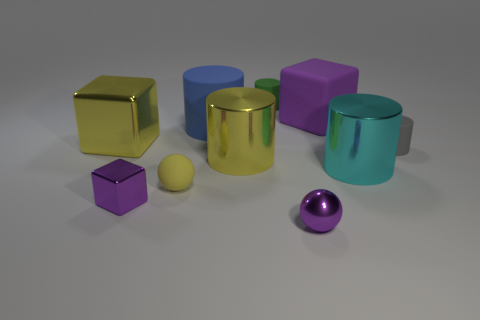There is a purple block that is behind the large yellow thing left of the purple shiny object that is on the left side of the tiny yellow sphere; what is it made of?
Your response must be concise. Rubber. Are there the same number of gray rubber objects on the right side of the purple matte cube and blocks?
Give a very brief answer. No. Are the large thing behind the blue cylinder and the big yellow thing behind the tiny gray rubber thing made of the same material?
Provide a short and direct response. No. What number of things are large purple rubber things or big cubes that are to the left of the purple rubber block?
Provide a short and direct response. 2. Are there any blue matte things of the same shape as the big cyan metallic thing?
Give a very brief answer. Yes. What size is the yellow metallic object in front of the large yellow object that is left of the purple block that is left of the yellow rubber thing?
Your answer should be compact. Large. Are there an equal number of metallic balls behind the purple ball and small shiny objects to the left of the gray matte cylinder?
Give a very brief answer. No. The blue cylinder that is made of the same material as the small green object is what size?
Give a very brief answer. Large. The tiny matte ball has what color?
Offer a terse response. Yellow. What number of rubber spheres are the same color as the tiny shiny ball?
Your answer should be compact. 0. 